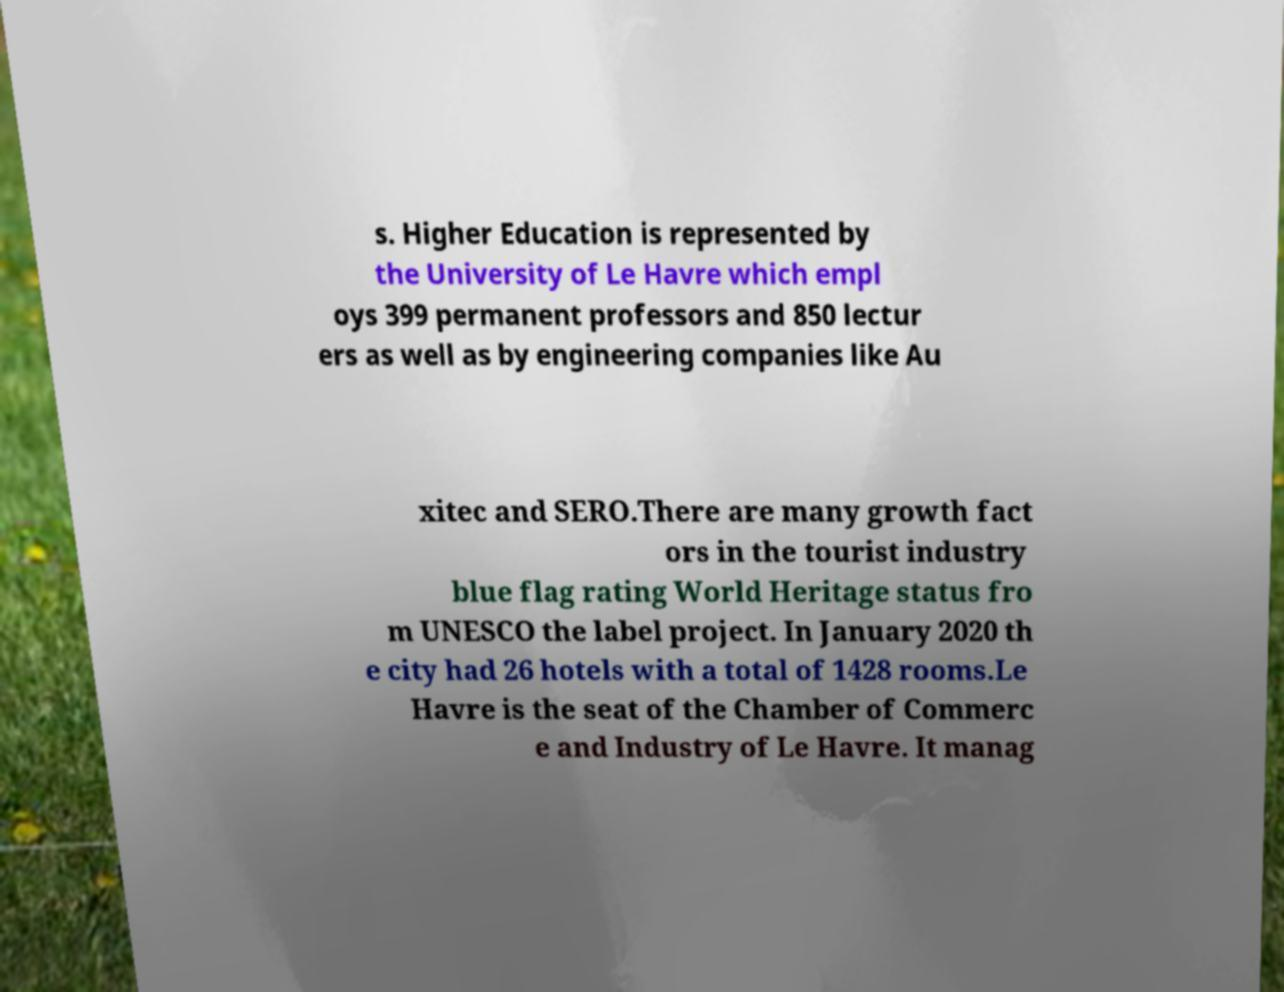Please identify and transcribe the text found in this image. s. Higher Education is represented by the University of Le Havre which empl oys 399 permanent professors and 850 lectur ers as well as by engineering companies like Au xitec and SERO.There are many growth fact ors in the tourist industry blue flag rating World Heritage status fro m UNESCO the label project. In January 2020 th e city had 26 hotels with a total of 1428 rooms.Le Havre is the seat of the Chamber of Commerc e and Industry of Le Havre. It manag 